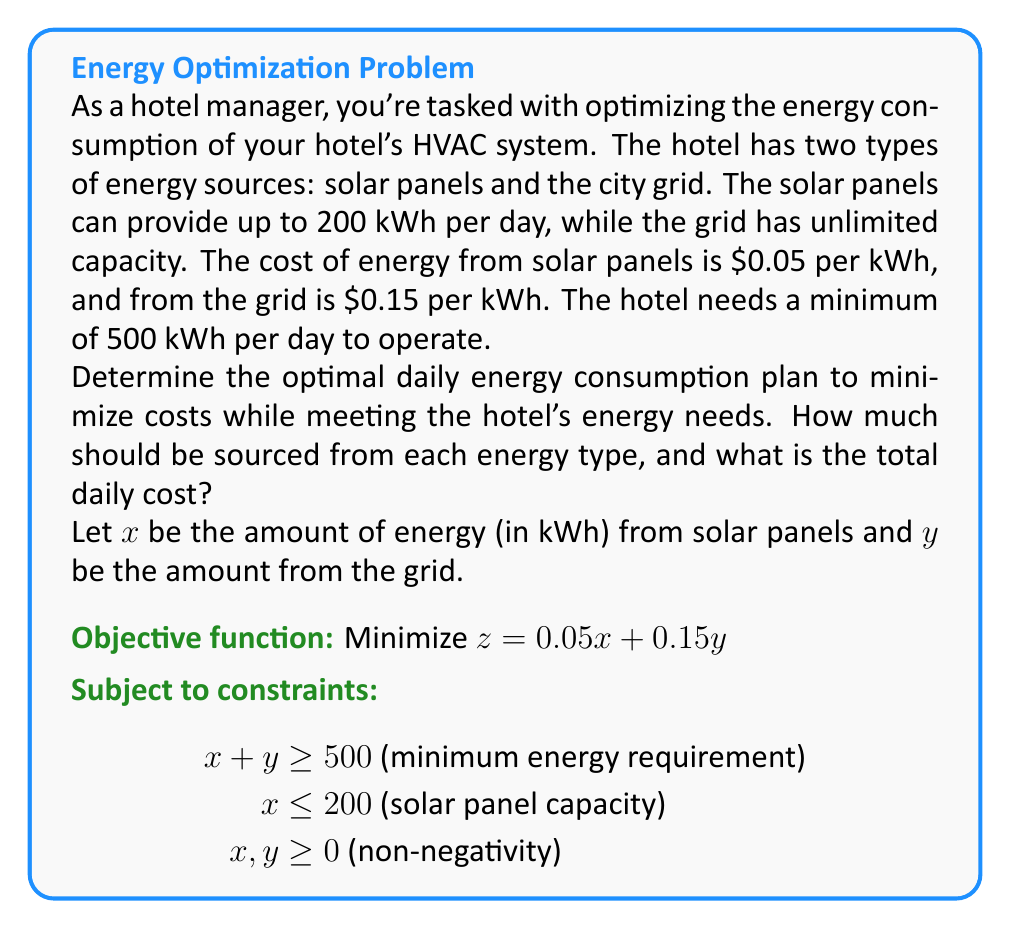Provide a solution to this math problem. To solve this linear programming problem, we'll use the graphical method:

1) Plot the constraints:
   - $x + y = 500$ (energy requirement line)
   - $x = 200$ (solar panel capacity line)
   - $x \geq 0$, $y \geq 0$ (first quadrant)

2) Identify the feasible region:
   The feasible region is the area that satisfies all constraints.

3) Find the corner points of the feasible region:
   A (0, 500), B (200, 300), C (200, 0)

4) Evaluate the objective function at each corner point:
   - A: $z = 0.05(0) + 0.15(500) = 75$
   - B: $z = 0.05(200) + 0.15(300) = 55$
   - C: $z = 0.05(200) + 0.15(0) = 10$ (doesn't meet energy requirement)

5) The optimal solution is at point B (200, 300), as it gives the lowest cost while meeting all constraints.

Therefore, the hotel should use 200 kWh from solar panels and 300 kWh from the grid daily.

The total daily cost is: $0.05(200) + 0.15(300) = $55
Answer: Solar: 200 kWh, Grid: 300 kWh, Total cost: $55/day 